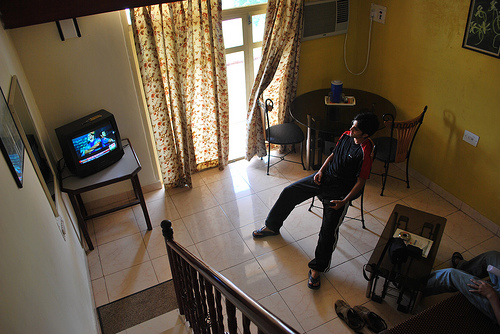What can you infer about the time of day or season from the image? The natural light flowing through the open balcony door suggests it might be daytime. Additionally, the attire of the person standing looks to be light, possibly indicating a warmer season or a comfortable indoor temperature. 